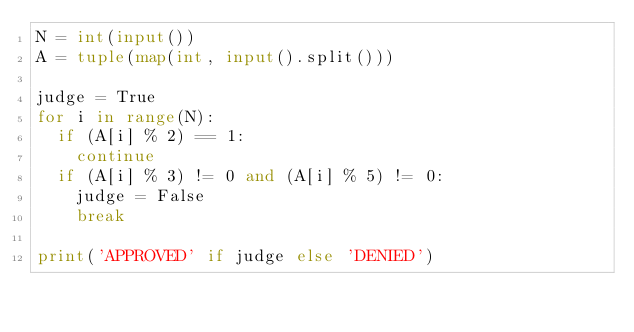<code> <loc_0><loc_0><loc_500><loc_500><_Python_>N = int(input())
A = tuple(map(int, input().split()))

judge = True
for i in range(N):
  if (A[i] % 2) == 1:
    continue
  if (A[i] % 3) != 0 and (A[i] % 5) != 0:
    judge = False
    break

print('APPROVED' if judge else 'DENIED')
</code> 